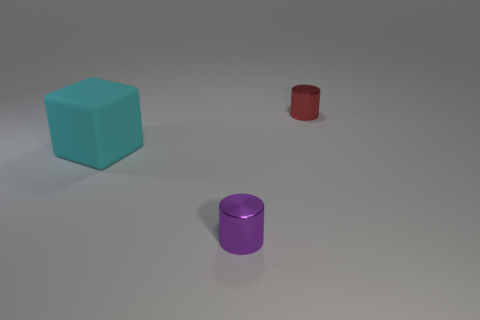Subtract all brown cylinders. Subtract all cyan blocks. How many cylinders are left? 2 Add 2 blue metal cubes. How many objects exist? 5 Subtract all red cylinders. How many cylinders are left? 1 Subtract 0 yellow blocks. How many objects are left? 3 Subtract all blocks. How many objects are left? 2 Subtract 1 cubes. How many cubes are left? 0 Subtract all blue blocks. How many purple cylinders are left? 1 Subtract all metallic objects. Subtract all large blocks. How many objects are left? 0 Add 3 red metallic objects. How many red metallic objects are left? 4 Add 2 tiny gray metallic objects. How many tiny gray metallic objects exist? 2 